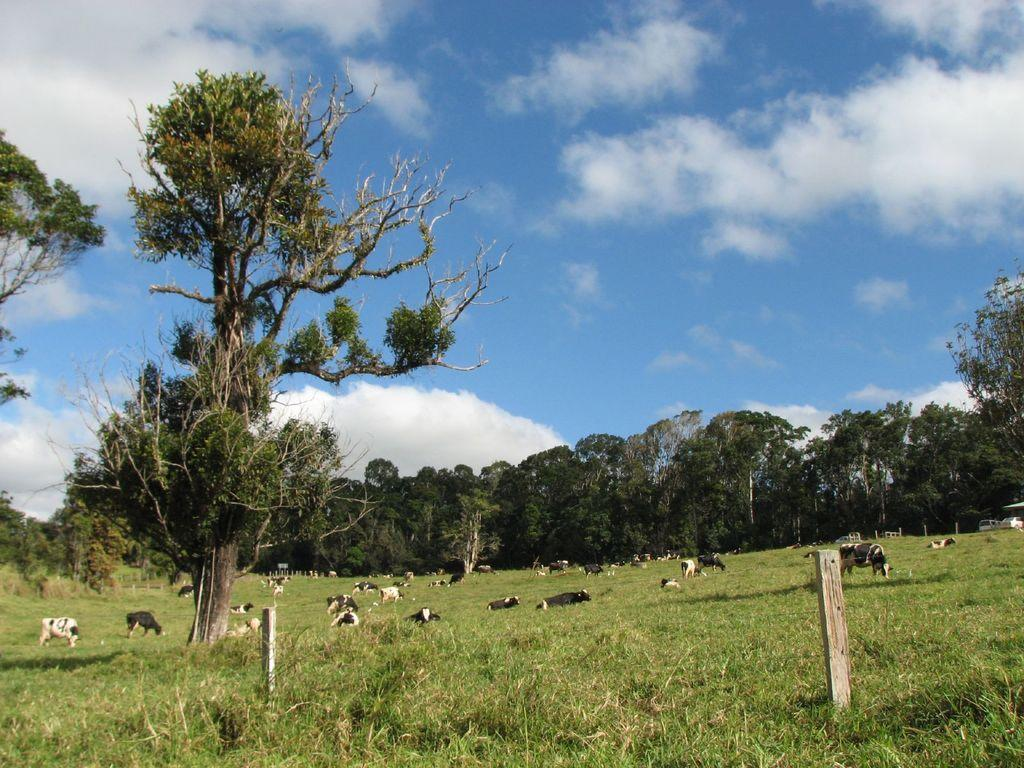What type of vegetation is present in the image? There are trees in the image. What animals can be seen in the image? There are cattle in the image. What is at the bottom of the image? There is grass at the bottom of the image. What is visible at the top of the image? There is sky visible at the top of the image. What can be seen in the sky? There are clouds in the sky. How many girls are playing with the powder in the image? There are no girls or powder present in the image. Is there a flame visible in the image? There is no flame visible in the image. 